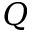<formula> <loc_0><loc_0><loc_500><loc_500>Q</formula> 